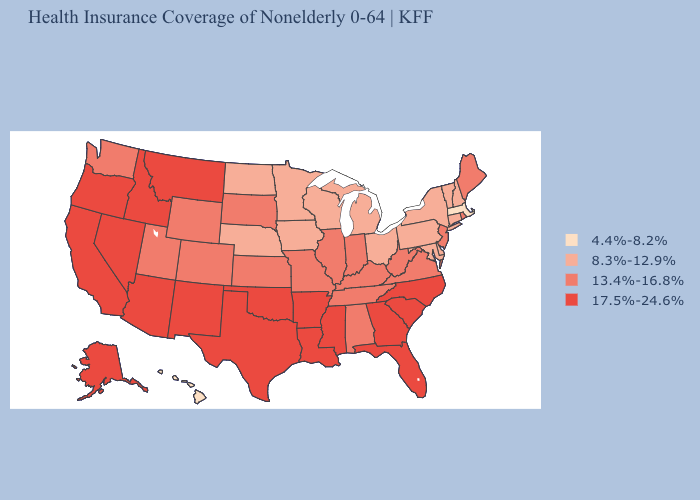Does Massachusetts have the lowest value in the Northeast?
Concise answer only. Yes. What is the value of Wyoming?
Quick response, please. 13.4%-16.8%. Name the states that have a value in the range 8.3%-12.9%?
Write a very short answer. Connecticut, Delaware, Iowa, Maryland, Michigan, Minnesota, Nebraska, New Hampshire, New York, North Dakota, Ohio, Pennsylvania, Vermont, Wisconsin. What is the value of Minnesota?
Answer briefly. 8.3%-12.9%. What is the lowest value in the USA?
Write a very short answer. 4.4%-8.2%. Name the states that have a value in the range 17.5%-24.6%?
Be succinct. Alaska, Arizona, Arkansas, California, Florida, Georgia, Idaho, Louisiana, Mississippi, Montana, Nevada, New Mexico, North Carolina, Oklahoma, Oregon, South Carolina, Texas. Does New Mexico have the lowest value in the West?
Give a very brief answer. No. Name the states that have a value in the range 4.4%-8.2%?
Answer briefly. Hawaii, Massachusetts. Name the states that have a value in the range 17.5%-24.6%?
Write a very short answer. Alaska, Arizona, Arkansas, California, Florida, Georgia, Idaho, Louisiana, Mississippi, Montana, Nevada, New Mexico, North Carolina, Oklahoma, Oregon, South Carolina, Texas. What is the lowest value in states that border New Jersey?
Quick response, please. 8.3%-12.9%. Name the states that have a value in the range 4.4%-8.2%?
Concise answer only. Hawaii, Massachusetts. What is the highest value in the USA?
Short answer required. 17.5%-24.6%. Name the states that have a value in the range 8.3%-12.9%?
Answer briefly. Connecticut, Delaware, Iowa, Maryland, Michigan, Minnesota, Nebraska, New Hampshire, New York, North Dakota, Ohio, Pennsylvania, Vermont, Wisconsin. Name the states that have a value in the range 8.3%-12.9%?
Give a very brief answer. Connecticut, Delaware, Iowa, Maryland, Michigan, Minnesota, Nebraska, New Hampshire, New York, North Dakota, Ohio, Pennsylvania, Vermont, Wisconsin. Name the states that have a value in the range 17.5%-24.6%?
Concise answer only. Alaska, Arizona, Arkansas, California, Florida, Georgia, Idaho, Louisiana, Mississippi, Montana, Nevada, New Mexico, North Carolina, Oklahoma, Oregon, South Carolina, Texas. 